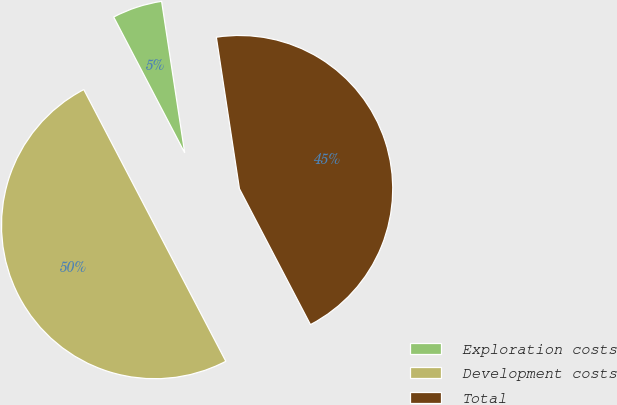Convert chart to OTSL. <chart><loc_0><loc_0><loc_500><loc_500><pie_chart><fcel>Exploration costs<fcel>Development costs<fcel>Total<nl><fcel>5.26%<fcel>50.0%<fcel>44.74%<nl></chart> 